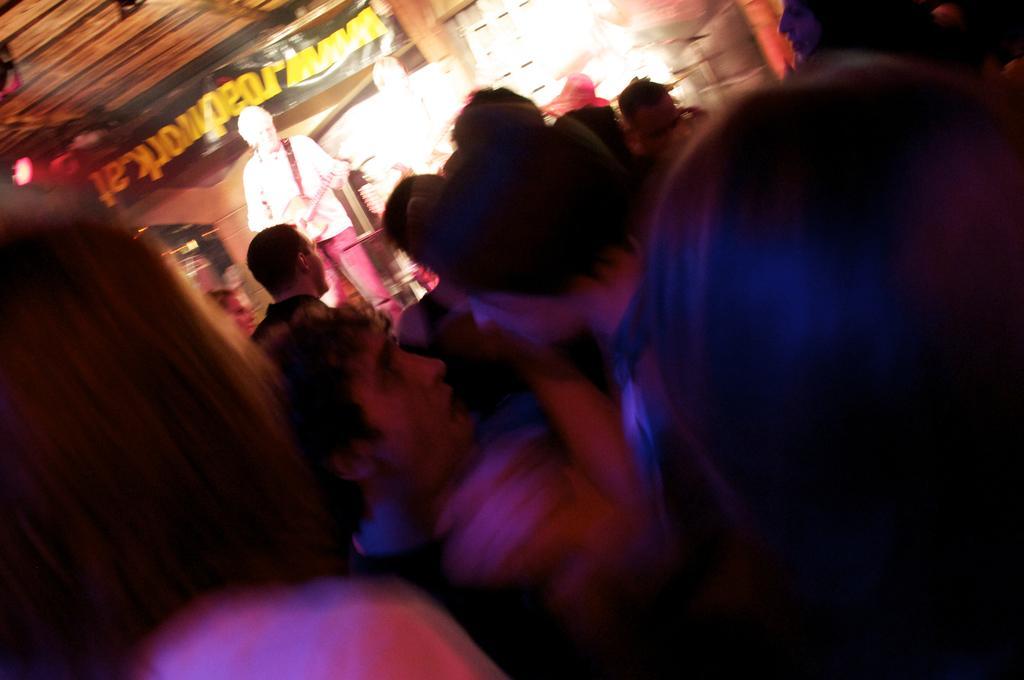Describe this image in one or two sentences. In this image, we can see a group of people. Here a person is holding a guitar. Background we can see a banner, some objects. 